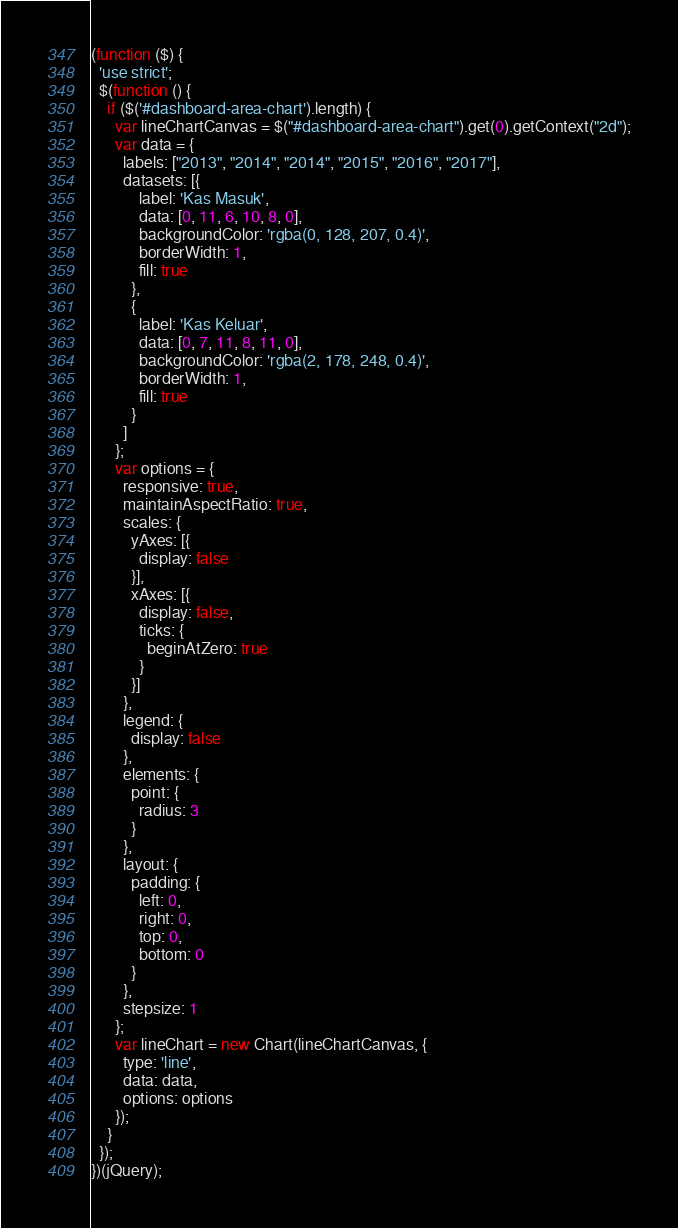Convert code to text. <code><loc_0><loc_0><loc_500><loc_500><_JavaScript_>(function ($) {
  'use strict';
  $(function () {
    if ($('#dashboard-area-chart').length) {
      var lineChartCanvas = $("#dashboard-area-chart").get(0).getContext("2d");
      var data = {
        labels: ["2013", "2014", "2014", "2015", "2016", "2017"],
        datasets: [{
            label: 'Kas Masuk',
            data: [0, 11, 6, 10, 8, 0],
            backgroundColor: 'rgba(0, 128, 207, 0.4)',
            borderWidth: 1,
            fill: true
          },
          {
            label: 'Kas Keluar',
            data: [0, 7, 11, 8, 11, 0],
            backgroundColor: 'rgba(2, 178, 248, 0.4)',
            borderWidth: 1,
            fill: true
          }
        ]
      };
      var options = {
        responsive: true,
        maintainAspectRatio: true,
        scales: {
          yAxes: [{
            display: false
          }],
          xAxes: [{
            display: false,
            ticks: {
              beginAtZero: true
            }
          }]
        },
        legend: {
          display: false
        },
        elements: {
          point: {
            radius: 3
          }
        },
        layout: {
          padding: {
            left: 0,
            right: 0,
            top: 0,
            bottom: 0
          }
        },
        stepsize: 1
      };
      var lineChart = new Chart(lineChartCanvas, {
        type: 'line',
        data: data,
        options: options
      });
    }
  });
})(jQuery);</code> 